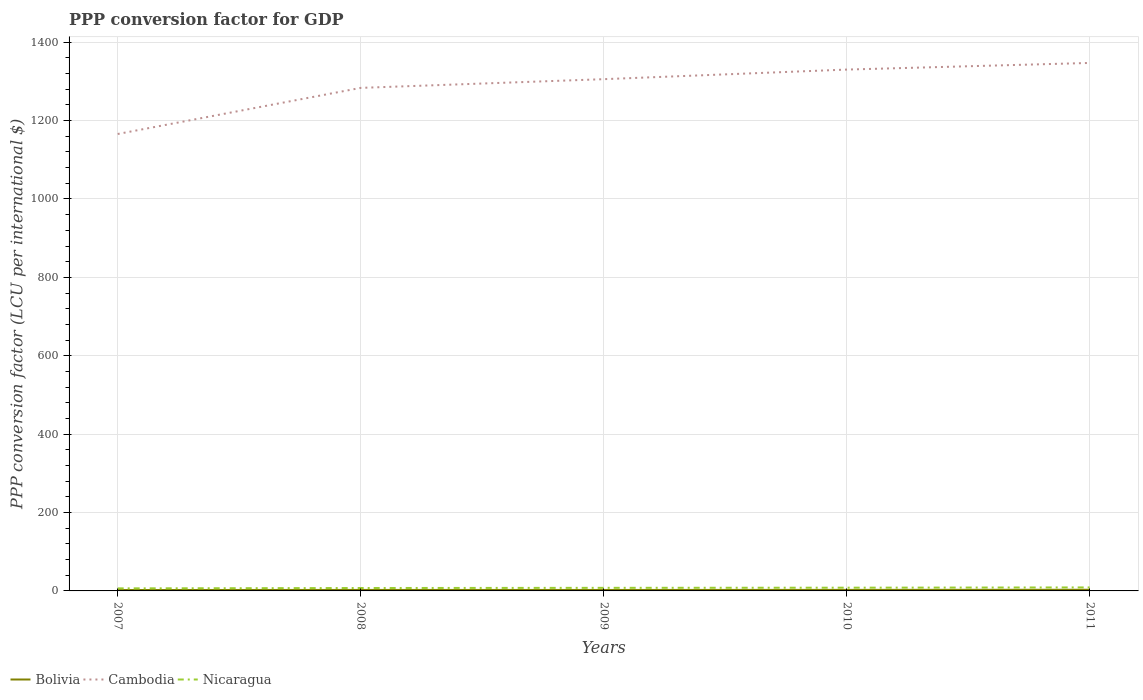How many different coloured lines are there?
Offer a very short reply. 3. Does the line corresponding to Bolivia intersect with the line corresponding to Cambodia?
Provide a short and direct response. No. Across all years, what is the maximum PPP conversion factor for GDP in Bolivia?
Your answer should be compact. 2.33. In which year was the PPP conversion factor for GDP in Nicaragua maximum?
Provide a short and direct response. 2007. What is the total PPP conversion factor for GDP in Bolivia in the graph?
Your answer should be compact. 0.08. What is the difference between the highest and the second highest PPP conversion factor for GDP in Nicaragua?
Keep it short and to the point. 2.39. What is the difference between the highest and the lowest PPP conversion factor for GDP in Cambodia?
Ensure brevity in your answer.  3. Does the graph contain any zero values?
Offer a terse response. No. Does the graph contain grids?
Offer a very short reply. Yes. How many legend labels are there?
Give a very brief answer. 3. What is the title of the graph?
Offer a very short reply. PPP conversion factor for GDP. What is the label or title of the X-axis?
Ensure brevity in your answer.  Years. What is the label or title of the Y-axis?
Provide a short and direct response. PPP conversion factor (LCU per international $). What is the PPP conversion factor (LCU per international $) in Bolivia in 2007?
Keep it short and to the point. 2.33. What is the PPP conversion factor (LCU per international $) in Cambodia in 2007?
Provide a short and direct response. 1165.78. What is the PPP conversion factor (LCU per international $) in Nicaragua in 2007?
Your response must be concise. 6.53. What is the PPP conversion factor (LCU per international $) of Bolivia in 2008?
Your response must be concise. 2.52. What is the PPP conversion factor (LCU per international $) of Cambodia in 2008?
Provide a succinct answer. 1283.45. What is the PPP conversion factor (LCU per international $) of Nicaragua in 2008?
Your answer should be compact. 7.44. What is the PPP conversion factor (LCU per international $) of Bolivia in 2009?
Your response must be concise. 2.44. What is the PPP conversion factor (LCU per international $) in Cambodia in 2009?
Your answer should be very brief. 1305.68. What is the PPP conversion factor (LCU per international $) of Nicaragua in 2009?
Provide a succinct answer. 7.87. What is the PPP conversion factor (LCU per international $) in Bolivia in 2010?
Provide a succinct answer. 2.62. What is the PPP conversion factor (LCU per international $) in Cambodia in 2010?
Offer a very short reply. 1330.18. What is the PPP conversion factor (LCU per international $) of Nicaragua in 2010?
Provide a short and direct response. 8.25. What is the PPP conversion factor (LCU per international $) in Bolivia in 2011?
Offer a terse response. 2.95. What is the PPP conversion factor (LCU per international $) of Cambodia in 2011?
Keep it short and to the point. 1347.11. What is the PPP conversion factor (LCU per international $) in Nicaragua in 2011?
Provide a succinct answer. 8.92. Across all years, what is the maximum PPP conversion factor (LCU per international $) of Bolivia?
Offer a very short reply. 2.95. Across all years, what is the maximum PPP conversion factor (LCU per international $) in Cambodia?
Keep it short and to the point. 1347.11. Across all years, what is the maximum PPP conversion factor (LCU per international $) of Nicaragua?
Provide a short and direct response. 8.92. Across all years, what is the minimum PPP conversion factor (LCU per international $) of Bolivia?
Ensure brevity in your answer.  2.33. Across all years, what is the minimum PPP conversion factor (LCU per international $) of Cambodia?
Ensure brevity in your answer.  1165.78. Across all years, what is the minimum PPP conversion factor (LCU per international $) in Nicaragua?
Your answer should be very brief. 6.53. What is the total PPP conversion factor (LCU per international $) in Bolivia in the graph?
Give a very brief answer. 12.86. What is the total PPP conversion factor (LCU per international $) of Cambodia in the graph?
Ensure brevity in your answer.  6432.21. What is the total PPP conversion factor (LCU per international $) of Nicaragua in the graph?
Make the answer very short. 39.01. What is the difference between the PPP conversion factor (LCU per international $) in Bolivia in 2007 and that in 2008?
Your answer should be very brief. -0.19. What is the difference between the PPP conversion factor (LCU per international $) of Cambodia in 2007 and that in 2008?
Your answer should be compact. -117.68. What is the difference between the PPP conversion factor (LCU per international $) of Nicaragua in 2007 and that in 2008?
Your answer should be compact. -0.91. What is the difference between the PPP conversion factor (LCU per international $) of Bolivia in 2007 and that in 2009?
Offer a very short reply. -0.11. What is the difference between the PPP conversion factor (LCU per international $) in Cambodia in 2007 and that in 2009?
Provide a short and direct response. -139.9. What is the difference between the PPP conversion factor (LCU per international $) of Nicaragua in 2007 and that in 2009?
Offer a terse response. -1.34. What is the difference between the PPP conversion factor (LCU per international $) in Bolivia in 2007 and that in 2010?
Your answer should be compact. -0.29. What is the difference between the PPP conversion factor (LCU per international $) of Cambodia in 2007 and that in 2010?
Offer a very short reply. -164.4. What is the difference between the PPP conversion factor (LCU per international $) of Nicaragua in 2007 and that in 2010?
Keep it short and to the point. -1.72. What is the difference between the PPP conversion factor (LCU per international $) of Bolivia in 2007 and that in 2011?
Ensure brevity in your answer.  -0.62. What is the difference between the PPP conversion factor (LCU per international $) of Cambodia in 2007 and that in 2011?
Your answer should be very brief. -181.34. What is the difference between the PPP conversion factor (LCU per international $) of Nicaragua in 2007 and that in 2011?
Your answer should be compact. -2.39. What is the difference between the PPP conversion factor (LCU per international $) of Bolivia in 2008 and that in 2009?
Offer a very short reply. 0.08. What is the difference between the PPP conversion factor (LCU per international $) in Cambodia in 2008 and that in 2009?
Give a very brief answer. -22.23. What is the difference between the PPP conversion factor (LCU per international $) of Nicaragua in 2008 and that in 2009?
Your answer should be compact. -0.43. What is the difference between the PPP conversion factor (LCU per international $) of Bolivia in 2008 and that in 2010?
Give a very brief answer. -0.1. What is the difference between the PPP conversion factor (LCU per international $) in Cambodia in 2008 and that in 2010?
Ensure brevity in your answer.  -46.73. What is the difference between the PPP conversion factor (LCU per international $) in Nicaragua in 2008 and that in 2010?
Offer a terse response. -0.81. What is the difference between the PPP conversion factor (LCU per international $) of Bolivia in 2008 and that in 2011?
Your response must be concise. -0.42. What is the difference between the PPP conversion factor (LCU per international $) of Cambodia in 2008 and that in 2011?
Give a very brief answer. -63.66. What is the difference between the PPP conversion factor (LCU per international $) of Nicaragua in 2008 and that in 2011?
Your response must be concise. -1.48. What is the difference between the PPP conversion factor (LCU per international $) of Bolivia in 2009 and that in 2010?
Make the answer very short. -0.18. What is the difference between the PPP conversion factor (LCU per international $) of Cambodia in 2009 and that in 2010?
Make the answer very short. -24.5. What is the difference between the PPP conversion factor (LCU per international $) of Nicaragua in 2009 and that in 2010?
Make the answer very short. -0.38. What is the difference between the PPP conversion factor (LCU per international $) of Bolivia in 2009 and that in 2011?
Give a very brief answer. -0.5. What is the difference between the PPP conversion factor (LCU per international $) of Cambodia in 2009 and that in 2011?
Ensure brevity in your answer.  -41.43. What is the difference between the PPP conversion factor (LCU per international $) in Nicaragua in 2009 and that in 2011?
Offer a terse response. -1.05. What is the difference between the PPP conversion factor (LCU per international $) of Bolivia in 2010 and that in 2011?
Offer a very short reply. -0.32. What is the difference between the PPP conversion factor (LCU per international $) of Cambodia in 2010 and that in 2011?
Keep it short and to the point. -16.94. What is the difference between the PPP conversion factor (LCU per international $) of Bolivia in 2007 and the PPP conversion factor (LCU per international $) of Cambodia in 2008?
Give a very brief answer. -1281.12. What is the difference between the PPP conversion factor (LCU per international $) of Bolivia in 2007 and the PPP conversion factor (LCU per international $) of Nicaragua in 2008?
Keep it short and to the point. -5.11. What is the difference between the PPP conversion factor (LCU per international $) of Cambodia in 2007 and the PPP conversion factor (LCU per international $) of Nicaragua in 2008?
Provide a short and direct response. 1158.34. What is the difference between the PPP conversion factor (LCU per international $) of Bolivia in 2007 and the PPP conversion factor (LCU per international $) of Cambodia in 2009?
Ensure brevity in your answer.  -1303.35. What is the difference between the PPP conversion factor (LCU per international $) in Bolivia in 2007 and the PPP conversion factor (LCU per international $) in Nicaragua in 2009?
Your response must be concise. -5.54. What is the difference between the PPP conversion factor (LCU per international $) in Cambodia in 2007 and the PPP conversion factor (LCU per international $) in Nicaragua in 2009?
Give a very brief answer. 1157.91. What is the difference between the PPP conversion factor (LCU per international $) of Bolivia in 2007 and the PPP conversion factor (LCU per international $) of Cambodia in 2010?
Make the answer very short. -1327.85. What is the difference between the PPP conversion factor (LCU per international $) of Bolivia in 2007 and the PPP conversion factor (LCU per international $) of Nicaragua in 2010?
Keep it short and to the point. -5.92. What is the difference between the PPP conversion factor (LCU per international $) in Cambodia in 2007 and the PPP conversion factor (LCU per international $) in Nicaragua in 2010?
Your answer should be very brief. 1157.53. What is the difference between the PPP conversion factor (LCU per international $) of Bolivia in 2007 and the PPP conversion factor (LCU per international $) of Cambodia in 2011?
Make the answer very short. -1344.79. What is the difference between the PPP conversion factor (LCU per international $) of Bolivia in 2007 and the PPP conversion factor (LCU per international $) of Nicaragua in 2011?
Offer a terse response. -6.59. What is the difference between the PPP conversion factor (LCU per international $) of Cambodia in 2007 and the PPP conversion factor (LCU per international $) of Nicaragua in 2011?
Give a very brief answer. 1156.86. What is the difference between the PPP conversion factor (LCU per international $) of Bolivia in 2008 and the PPP conversion factor (LCU per international $) of Cambodia in 2009?
Offer a terse response. -1303.16. What is the difference between the PPP conversion factor (LCU per international $) in Bolivia in 2008 and the PPP conversion factor (LCU per international $) in Nicaragua in 2009?
Keep it short and to the point. -5.35. What is the difference between the PPP conversion factor (LCU per international $) of Cambodia in 2008 and the PPP conversion factor (LCU per international $) of Nicaragua in 2009?
Provide a succinct answer. 1275.58. What is the difference between the PPP conversion factor (LCU per international $) in Bolivia in 2008 and the PPP conversion factor (LCU per international $) in Cambodia in 2010?
Your answer should be very brief. -1327.66. What is the difference between the PPP conversion factor (LCU per international $) in Bolivia in 2008 and the PPP conversion factor (LCU per international $) in Nicaragua in 2010?
Provide a succinct answer. -5.73. What is the difference between the PPP conversion factor (LCU per international $) in Cambodia in 2008 and the PPP conversion factor (LCU per international $) in Nicaragua in 2010?
Give a very brief answer. 1275.2. What is the difference between the PPP conversion factor (LCU per international $) of Bolivia in 2008 and the PPP conversion factor (LCU per international $) of Cambodia in 2011?
Give a very brief answer. -1344.59. What is the difference between the PPP conversion factor (LCU per international $) of Bolivia in 2008 and the PPP conversion factor (LCU per international $) of Nicaragua in 2011?
Offer a terse response. -6.4. What is the difference between the PPP conversion factor (LCU per international $) in Cambodia in 2008 and the PPP conversion factor (LCU per international $) in Nicaragua in 2011?
Ensure brevity in your answer.  1274.54. What is the difference between the PPP conversion factor (LCU per international $) in Bolivia in 2009 and the PPP conversion factor (LCU per international $) in Cambodia in 2010?
Provide a succinct answer. -1327.74. What is the difference between the PPP conversion factor (LCU per international $) of Bolivia in 2009 and the PPP conversion factor (LCU per international $) of Nicaragua in 2010?
Ensure brevity in your answer.  -5.81. What is the difference between the PPP conversion factor (LCU per international $) in Cambodia in 2009 and the PPP conversion factor (LCU per international $) in Nicaragua in 2010?
Your answer should be compact. 1297.43. What is the difference between the PPP conversion factor (LCU per international $) in Bolivia in 2009 and the PPP conversion factor (LCU per international $) in Cambodia in 2011?
Offer a very short reply. -1344.67. What is the difference between the PPP conversion factor (LCU per international $) in Bolivia in 2009 and the PPP conversion factor (LCU per international $) in Nicaragua in 2011?
Make the answer very short. -6.48. What is the difference between the PPP conversion factor (LCU per international $) in Cambodia in 2009 and the PPP conversion factor (LCU per international $) in Nicaragua in 2011?
Provide a succinct answer. 1296.76. What is the difference between the PPP conversion factor (LCU per international $) of Bolivia in 2010 and the PPP conversion factor (LCU per international $) of Cambodia in 2011?
Give a very brief answer. -1344.49. What is the difference between the PPP conversion factor (LCU per international $) in Bolivia in 2010 and the PPP conversion factor (LCU per international $) in Nicaragua in 2011?
Your answer should be compact. -6.29. What is the difference between the PPP conversion factor (LCU per international $) in Cambodia in 2010 and the PPP conversion factor (LCU per international $) in Nicaragua in 2011?
Offer a very short reply. 1321.26. What is the average PPP conversion factor (LCU per international $) in Bolivia per year?
Your answer should be very brief. 2.57. What is the average PPP conversion factor (LCU per international $) of Cambodia per year?
Give a very brief answer. 1286.44. What is the average PPP conversion factor (LCU per international $) in Nicaragua per year?
Provide a succinct answer. 7.8. In the year 2007, what is the difference between the PPP conversion factor (LCU per international $) in Bolivia and PPP conversion factor (LCU per international $) in Cambodia?
Keep it short and to the point. -1163.45. In the year 2007, what is the difference between the PPP conversion factor (LCU per international $) of Bolivia and PPP conversion factor (LCU per international $) of Nicaragua?
Your response must be concise. -4.2. In the year 2007, what is the difference between the PPP conversion factor (LCU per international $) in Cambodia and PPP conversion factor (LCU per international $) in Nicaragua?
Provide a succinct answer. 1159.25. In the year 2008, what is the difference between the PPP conversion factor (LCU per international $) of Bolivia and PPP conversion factor (LCU per international $) of Cambodia?
Your answer should be very brief. -1280.93. In the year 2008, what is the difference between the PPP conversion factor (LCU per international $) of Bolivia and PPP conversion factor (LCU per international $) of Nicaragua?
Ensure brevity in your answer.  -4.92. In the year 2008, what is the difference between the PPP conversion factor (LCU per international $) in Cambodia and PPP conversion factor (LCU per international $) in Nicaragua?
Ensure brevity in your answer.  1276.01. In the year 2009, what is the difference between the PPP conversion factor (LCU per international $) of Bolivia and PPP conversion factor (LCU per international $) of Cambodia?
Your response must be concise. -1303.24. In the year 2009, what is the difference between the PPP conversion factor (LCU per international $) of Bolivia and PPP conversion factor (LCU per international $) of Nicaragua?
Your answer should be very brief. -5.43. In the year 2009, what is the difference between the PPP conversion factor (LCU per international $) in Cambodia and PPP conversion factor (LCU per international $) in Nicaragua?
Make the answer very short. 1297.81. In the year 2010, what is the difference between the PPP conversion factor (LCU per international $) in Bolivia and PPP conversion factor (LCU per international $) in Cambodia?
Keep it short and to the point. -1327.56. In the year 2010, what is the difference between the PPP conversion factor (LCU per international $) in Bolivia and PPP conversion factor (LCU per international $) in Nicaragua?
Provide a succinct answer. -5.63. In the year 2010, what is the difference between the PPP conversion factor (LCU per international $) in Cambodia and PPP conversion factor (LCU per international $) in Nicaragua?
Ensure brevity in your answer.  1321.93. In the year 2011, what is the difference between the PPP conversion factor (LCU per international $) of Bolivia and PPP conversion factor (LCU per international $) of Cambodia?
Your response must be concise. -1344.17. In the year 2011, what is the difference between the PPP conversion factor (LCU per international $) of Bolivia and PPP conversion factor (LCU per international $) of Nicaragua?
Keep it short and to the point. -5.97. In the year 2011, what is the difference between the PPP conversion factor (LCU per international $) in Cambodia and PPP conversion factor (LCU per international $) in Nicaragua?
Your answer should be compact. 1338.2. What is the ratio of the PPP conversion factor (LCU per international $) of Bolivia in 2007 to that in 2008?
Make the answer very short. 0.92. What is the ratio of the PPP conversion factor (LCU per international $) of Cambodia in 2007 to that in 2008?
Provide a short and direct response. 0.91. What is the ratio of the PPP conversion factor (LCU per international $) of Nicaragua in 2007 to that in 2008?
Make the answer very short. 0.88. What is the ratio of the PPP conversion factor (LCU per international $) of Bolivia in 2007 to that in 2009?
Offer a very short reply. 0.95. What is the ratio of the PPP conversion factor (LCU per international $) of Cambodia in 2007 to that in 2009?
Provide a short and direct response. 0.89. What is the ratio of the PPP conversion factor (LCU per international $) of Nicaragua in 2007 to that in 2009?
Offer a very short reply. 0.83. What is the ratio of the PPP conversion factor (LCU per international $) of Bolivia in 2007 to that in 2010?
Ensure brevity in your answer.  0.89. What is the ratio of the PPP conversion factor (LCU per international $) of Cambodia in 2007 to that in 2010?
Ensure brevity in your answer.  0.88. What is the ratio of the PPP conversion factor (LCU per international $) in Nicaragua in 2007 to that in 2010?
Make the answer very short. 0.79. What is the ratio of the PPP conversion factor (LCU per international $) in Bolivia in 2007 to that in 2011?
Your response must be concise. 0.79. What is the ratio of the PPP conversion factor (LCU per international $) in Cambodia in 2007 to that in 2011?
Give a very brief answer. 0.87. What is the ratio of the PPP conversion factor (LCU per international $) in Nicaragua in 2007 to that in 2011?
Your response must be concise. 0.73. What is the ratio of the PPP conversion factor (LCU per international $) of Bolivia in 2008 to that in 2009?
Provide a succinct answer. 1.03. What is the ratio of the PPP conversion factor (LCU per international $) of Nicaragua in 2008 to that in 2009?
Ensure brevity in your answer.  0.95. What is the ratio of the PPP conversion factor (LCU per international $) of Bolivia in 2008 to that in 2010?
Your answer should be very brief. 0.96. What is the ratio of the PPP conversion factor (LCU per international $) of Cambodia in 2008 to that in 2010?
Your answer should be compact. 0.96. What is the ratio of the PPP conversion factor (LCU per international $) of Nicaragua in 2008 to that in 2010?
Your answer should be very brief. 0.9. What is the ratio of the PPP conversion factor (LCU per international $) of Bolivia in 2008 to that in 2011?
Provide a short and direct response. 0.86. What is the ratio of the PPP conversion factor (LCU per international $) of Cambodia in 2008 to that in 2011?
Offer a terse response. 0.95. What is the ratio of the PPP conversion factor (LCU per international $) of Nicaragua in 2008 to that in 2011?
Offer a terse response. 0.83. What is the ratio of the PPP conversion factor (LCU per international $) in Bolivia in 2009 to that in 2010?
Offer a very short reply. 0.93. What is the ratio of the PPP conversion factor (LCU per international $) in Cambodia in 2009 to that in 2010?
Provide a short and direct response. 0.98. What is the ratio of the PPP conversion factor (LCU per international $) in Nicaragua in 2009 to that in 2010?
Ensure brevity in your answer.  0.95. What is the ratio of the PPP conversion factor (LCU per international $) of Bolivia in 2009 to that in 2011?
Your answer should be very brief. 0.83. What is the ratio of the PPP conversion factor (LCU per international $) in Cambodia in 2009 to that in 2011?
Provide a short and direct response. 0.97. What is the ratio of the PPP conversion factor (LCU per international $) in Nicaragua in 2009 to that in 2011?
Ensure brevity in your answer.  0.88. What is the ratio of the PPP conversion factor (LCU per international $) in Bolivia in 2010 to that in 2011?
Your answer should be compact. 0.89. What is the ratio of the PPP conversion factor (LCU per international $) of Cambodia in 2010 to that in 2011?
Provide a short and direct response. 0.99. What is the ratio of the PPP conversion factor (LCU per international $) of Nicaragua in 2010 to that in 2011?
Give a very brief answer. 0.93. What is the difference between the highest and the second highest PPP conversion factor (LCU per international $) of Bolivia?
Ensure brevity in your answer.  0.32. What is the difference between the highest and the second highest PPP conversion factor (LCU per international $) of Cambodia?
Provide a short and direct response. 16.94. What is the difference between the highest and the lowest PPP conversion factor (LCU per international $) in Bolivia?
Your response must be concise. 0.62. What is the difference between the highest and the lowest PPP conversion factor (LCU per international $) of Cambodia?
Your response must be concise. 181.34. What is the difference between the highest and the lowest PPP conversion factor (LCU per international $) of Nicaragua?
Your response must be concise. 2.39. 